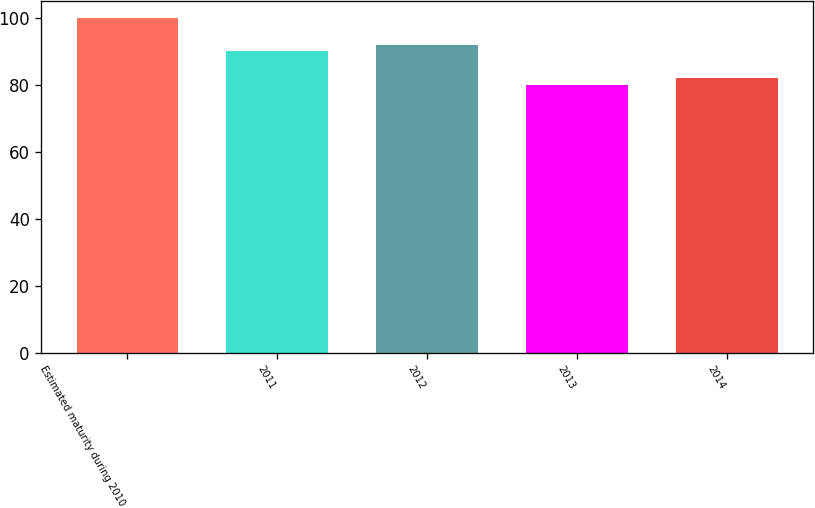Convert chart to OTSL. <chart><loc_0><loc_0><loc_500><loc_500><bar_chart><fcel>Estimated maturity during 2010<fcel>2011<fcel>2012<fcel>2013<fcel>2014<nl><fcel>100<fcel>90<fcel>92<fcel>80<fcel>82<nl></chart> 